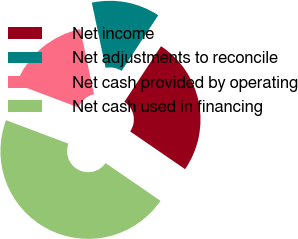<chart> <loc_0><loc_0><loc_500><loc_500><pie_chart><fcel>Net income<fcel>Net adjustments to reconcile<fcel>Net cash provided by operating<fcel>Net cash used in financing<nl><fcel>25.31%<fcel>12.59%<fcel>15.95%<fcel>46.15%<nl></chart> 